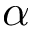Convert formula to latex. <formula><loc_0><loc_0><loc_500><loc_500>\alpha</formula> 